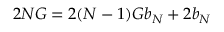Convert formula to latex. <formula><loc_0><loc_0><loc_500><loc_500>2 N G = 2 ( N - 1 ) G b _ { N } + 2 b _ { N }</formula> 